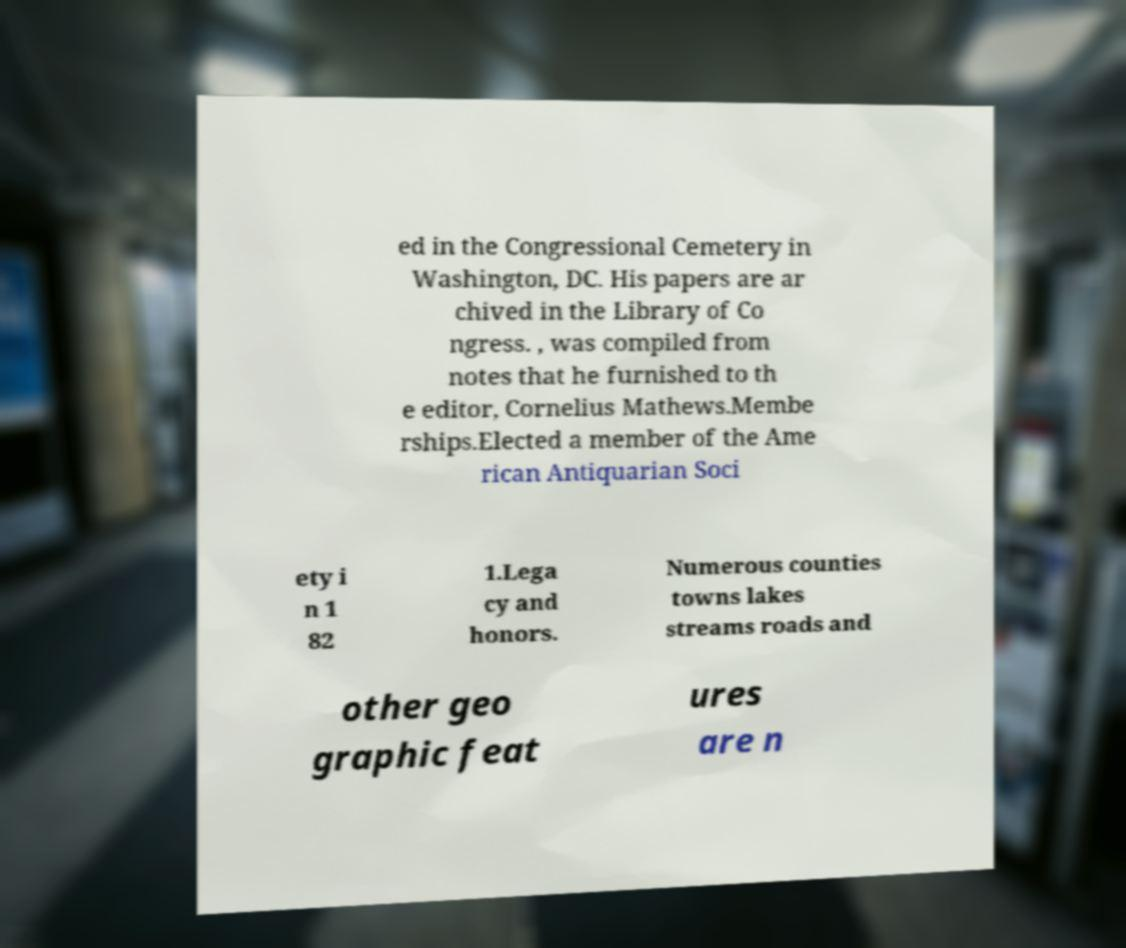Can you read and provide the text displayed in the image?This photo seems to have some interesting text. Can you extract and type it out for me? ed in the Congressional Cemetery in Washington, DC. His papers are ar chived in the Library of Co ngress. , was compiled from notes that he furnished to th e editor, Cornelius Mathews.Membe rships.Elected a member of the Ame rican Antiquarian Soci ety i n 1 82 1.Lega cy and honors. Numerous counties towns lakes streams roads and other geo graphic feat ures are n 